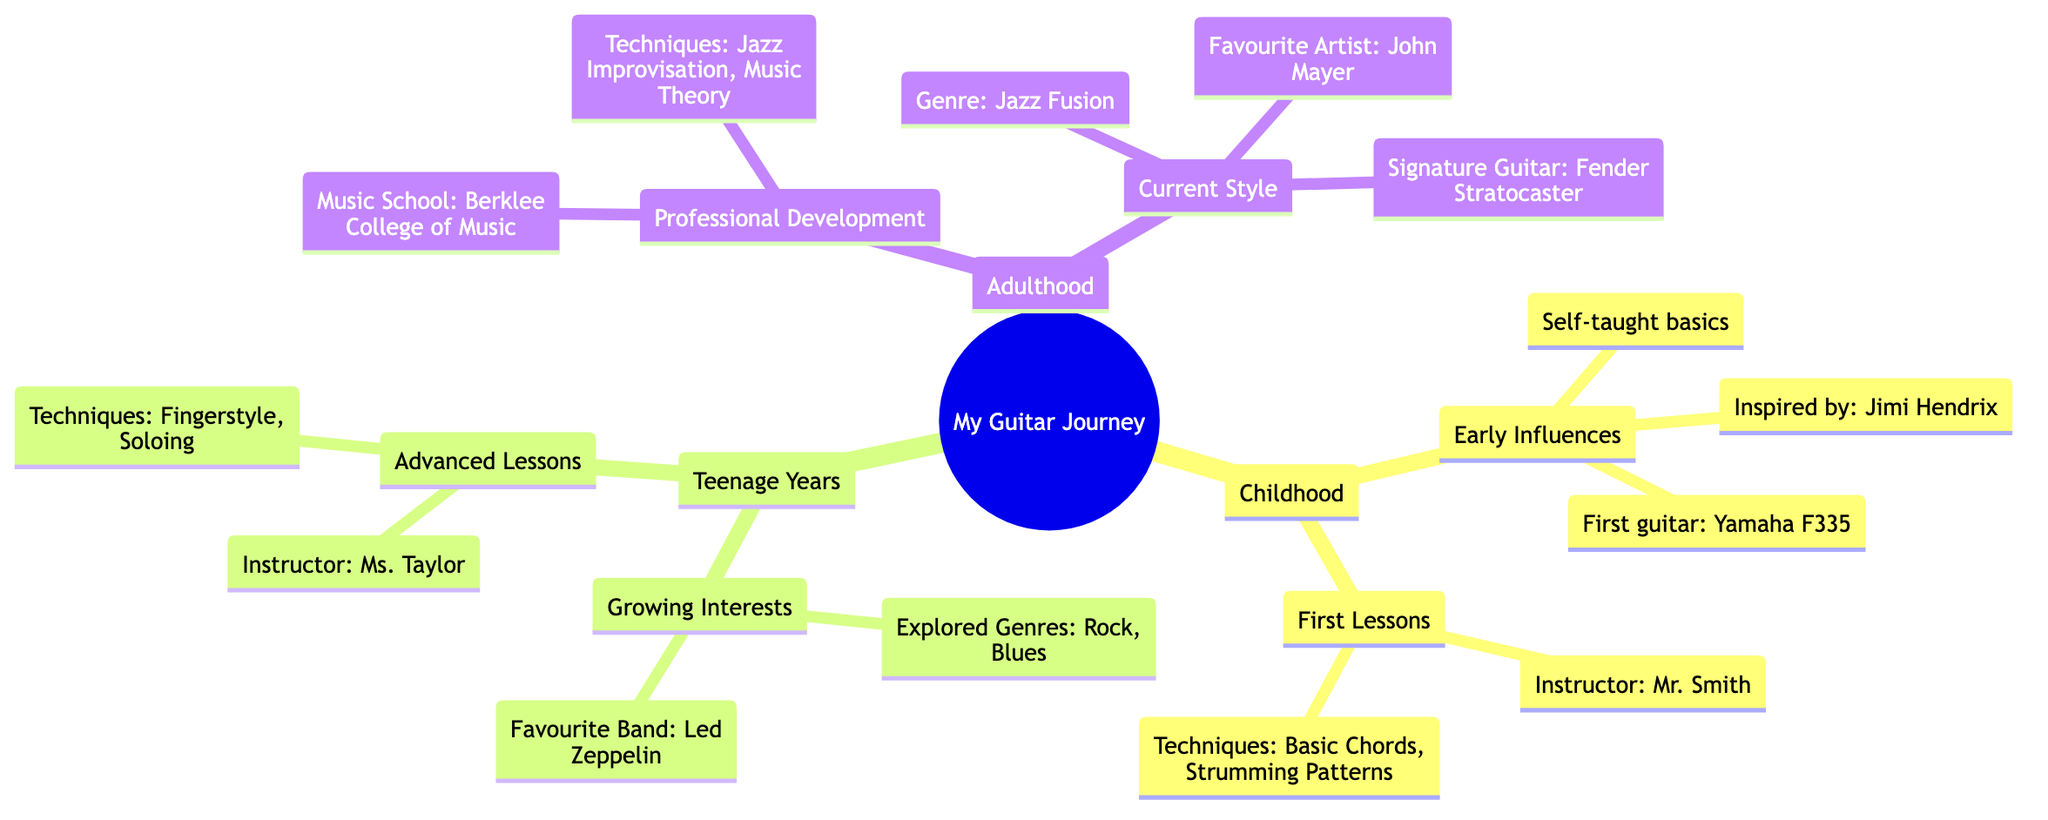What is the first guitar mentioned in the diagram? The first guitar is listed under the "Early Influences" section in "Childhood." It states "First guitar: Yamaha F335."
Answer: Yamaha F335 Who was the instructor during the first lessons? The instructor for the first lessons is mentioned under the "First Lessons" section in "Childhood." It states "Instructor: Mr. Smith."
Answer: Mr. Smith What genre did I explore during my teenage years? The exploration of genres is found under the "Growing Interests" section in "Teenage Years," which states "Explored Genres: Rock, Blues." The genres mentioned are Rock and Blues.
Answer: Rock, Blues Which music school is represented in adulthood? The music school attended is mentioned under the "Professional Development" in "Adulthood." It states "Music School: Berklee College of Music."
Answer: Berklee College of Music What is my favorite artist in the current style section? The favorite artist is indicated under the "Current Style" section in "Adulthood," which states "Favourite Artist: John Mayer."
Answer: John Mayer What techniques were learned in the advanced lessons? The techniques learned are listed under the "Advanced Lessons" section in "Teenage Years." It states "Techniques: Fingerstyle, Soloing."
Answer: Fingerstyle, Soloing How many sections are there in the "Adulthood" branch? The "Adulthood" branch has two sections: "Professional Development" and "Current Style." Therefore, the answer is derived from counting the children under the "Adulthood" node.
Answer: 2 What instrument does the signature guitar refer to? The signature guitar is specified under the "Current Style" section in "Adulthood." It states "Signature Guitar: Fender Stratocaster."
Answer: Fender Stratocaster Which artist inspired my early influences? The inspiration is listed in the "Early Influences" section in "Childhood." It states "Inspired by: Jimi Hendrix."
Answer: Jimi Hendrix 